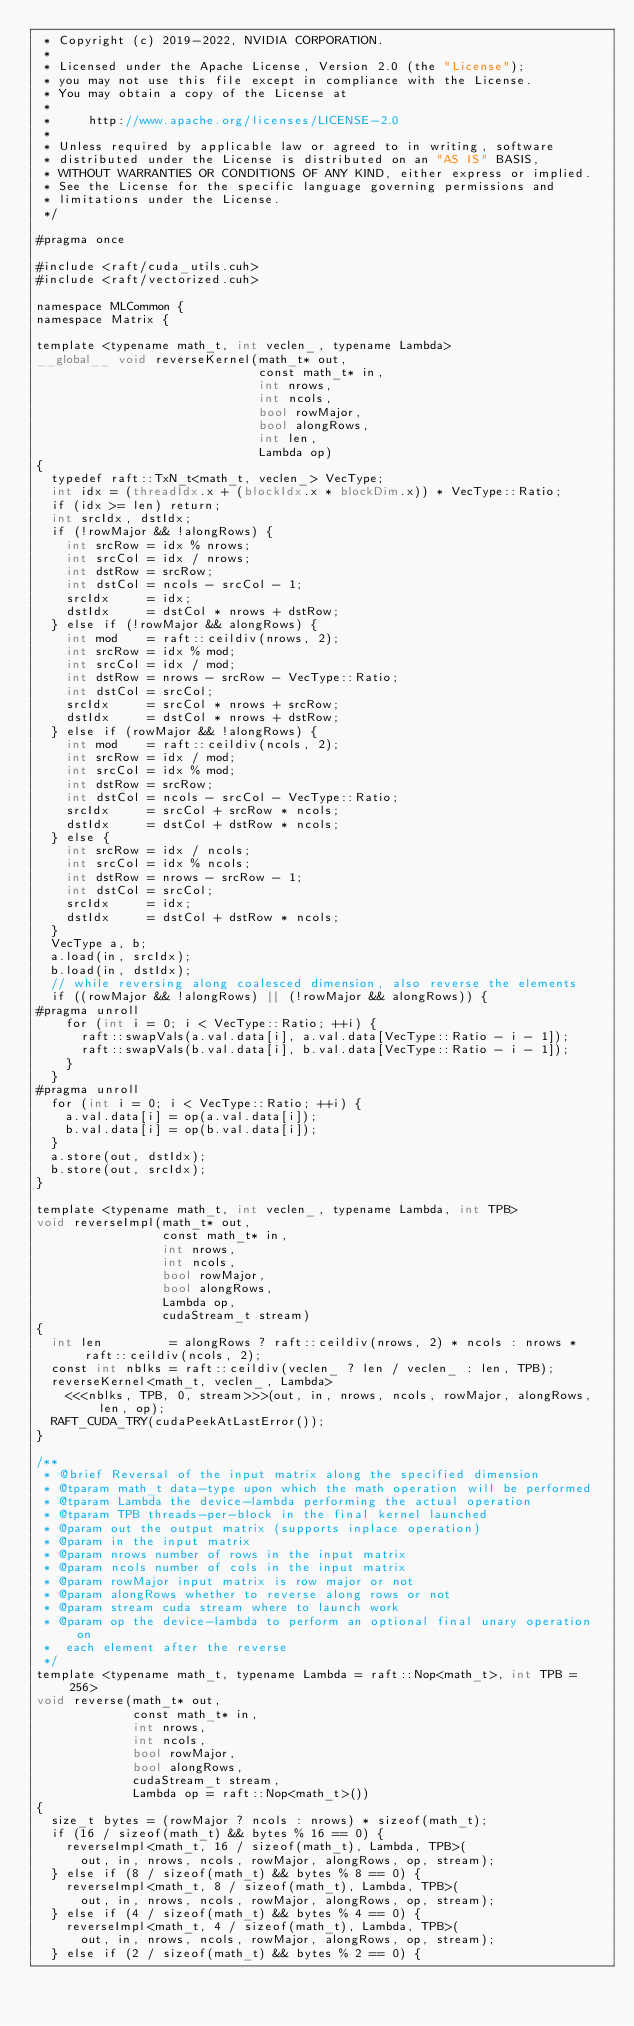<code> <loc_0><loc_0><loc_500><loc_500><_Cuda_> * Copyright (c) 2019-2022, NVIDIA CORPORATION.
 *
 * Licensed under the Apache License, Version 2.0 (the "License");
 * you may not use this file except in compliance with the License.
 * You may obtain a copy of the License at
 *
 *     http://www.apache.org/licenses/LICENSE-2.0
 *
 * Unless required by applicable law or agreed to in writing, software
 * distributed under the License is distributed on an "AS IS" BASIS,
 * WITHOUT WARRANTIES OR CONDITIONS OF ANY KIND, either express or implied.
 * See the License for the specific language governing permissions and
 * limitations under the License.
 */

#pragma once

#include <raft/cuda_utils.cuh>
#include <raft/vectorized.cuh>

namespace MLCommon {
namespace Matrix {

template <typename math_t, int veclen_, typename Lambda>
__global__ void reverseKernel(math_t* out,
                              const math_t* in,
                              int nrows,
                              int ncols,
                              bool rowMajor,
                              bool alongRows,
                              int len,
                              Lambda op)
{
  typedef raft::TxN_t<math_t, veclen_> VecType;
  int idx = (threadIdx.x + (blockIdx.x * blockDim.x)) * VecType::Ratio;
  if (idx >= len) return;
  int srcIdx, dstIdx;
  if (!rowMajor && !alongRows) {
    int srcRow = idx % nrows;
    int srcCol = idx / nrows;
    int dstRow = srcRow;
    int dstCol = ncols - srcCol - 1;
    srcIdx     = idx;
    dstIdx     = dstCol * nrows + dstRow;
  } else if (!rowMajor && alongRows) {
    int mod    = raft::ceildiv(nrows, 2);
    int srcRow = idx % mod;
    int srcCol = idx / mod;
    int dstRow = nrows - srcRow - VecType::Ratio;
    int dstCol = srcCol;
    srcIdx     = srcCol * nrows + srcRow;
    dstIdx     = dstCol * nrows + dstRow;
  } else if (rowMajor && !alongRows) {
    int mod    = raft::ceildiv(ncols, 2);
    int srcRow = idx / mod;
    int srcCol = idx % mod;
    int dstRow = srcRow;
    int dstCol = ncols - srcCol - VecType::Ratio;
    srcIdx     = srcCol + srcRow * ncols;
    dstIdx     = dstCol + dstRow * ncols;
  } else {
    int srcRow = idx / ncols;
    int srcCol = idx % ncols;
    int dstRow = nrows - srcRow - 1;
    int dstCol = srcCol;
    srcIdx     = idx;
    dstIdx     = dstCol + dstRow * ncols;
  }
  VecType a, b;
  a.load(in, srcIdx);
  b.load(in, dstIdx);
  // while reversing along coalesced dimension, also reverse the elements
  if ((rowMajor && !alongRows) || (!rowMajor && alongRows)) {
#pragma unroll
    for (int i = 0; i < VecType::Ratio; ++i) {
      raft::swapVals(a.val.data[i], a.val.data[VecType::Ratio - i - 1]);
      raft::swapVals(b.val.data[i], b.val.data[VecType::Ratio - i - 1]);
    }
  }
#pragma unroll
  for (int i = 0; i < VecType::Ratio; ++i) {
    a.val.data[i] = op(a.val.data[i]);
    b.val.data[i] = op(b.val.data[i]);
  }
  a.store(out, dstIdx);
  b.store(out, srcIdx);
}

template <typename math_t, int veclen_, typename Lambda, int TPB>
void reverseImpl(math_t* out,
                 const math_t* in,
                 int nrows,
                 int ncols,
                 bool rowMajor,
                 bool alongRows,
                 Lambda op,
                 cudaStream_t stream)
{
  int len         = alongRows ? raft::ceildiv(nrows, 2) * ncols : nrows * raft::ceildiv(ncols, 2);
  const int nblks = raft::ceildiv(veclen_ ? len / veclen_ : len, TPB);
  reverseKernel<math_t, veclen_, Lambda>
    <<<nblks, TPB, 0, stream>>>(out, in, nrows, ncols, rowMajor, alongRows, len, op);
  RAFT_CUDA_TRY(cudaPeekAtLastError());
}

/**
 * @brief Reversal of the input matrix along the specified dimension
 * @tparam math_t data-type upon which the math operation will be performed
 * @tparam Lambda the device-lambda performing the actual operation
 * @tparam TPB threads-per-block in the final kernel launched
 * @param out the output matrix (supports inplace operation)
 * @param in the input matrix
 * @param nrows number of rows in the input matrix
 * @param ncols number of cols in the input matrix
 * @param rowMajor input matrix is row major or not
 * @param alongRows whether to reverse along rows or not
 * @param stream cuda stream where to launch work
 * @param op the device-lambda to perform an optional final unary operation on
 *  each element after the reverse
 */
template <typename math_t, typename Lambda = raft::Nop<math_t>, int TPB = 256>
void reverse(math_t* out,
             const math_t* in,
             int nrows,
             int ncols,
             bool rowMajor,
             bool alongRows,
             cudaStream_t stream,
             Lambda op = raft::Nop<math_t>())
{
  size_t bytes = (rowMajor ? ncols : nrows) * sizeof(math_t);
  if (16 / sizeof(math_t) && bytes % 16 == 0) {
    reverseImpl<math_t, 16 / sizeof(math_t), Lambda, TPB>(
      out, in, nrows, ncols, rowMajor, alongRows, op, stream);
  } else if (8 / sizeof(math_t) && bytes % 8 == 0) {
    reverseImpl<math_t, 8 / sizeof(math_t), Lambda, TPB>(
      out, in, nrows, ncols, rowMajor, alongRows, op, stream);
  } else if (4 / sizeof(math_t) && bytes % 4 == 0) {
    reverseImpl<math_t, 4 / sizeof(math_t), Lambda, TPB>(
      out, in, nrows, ncols, rowMajor, alongRows, op, stream);
  } else if (2 / sizeof(math_t) && bytes % 2 == 0) {</code> 